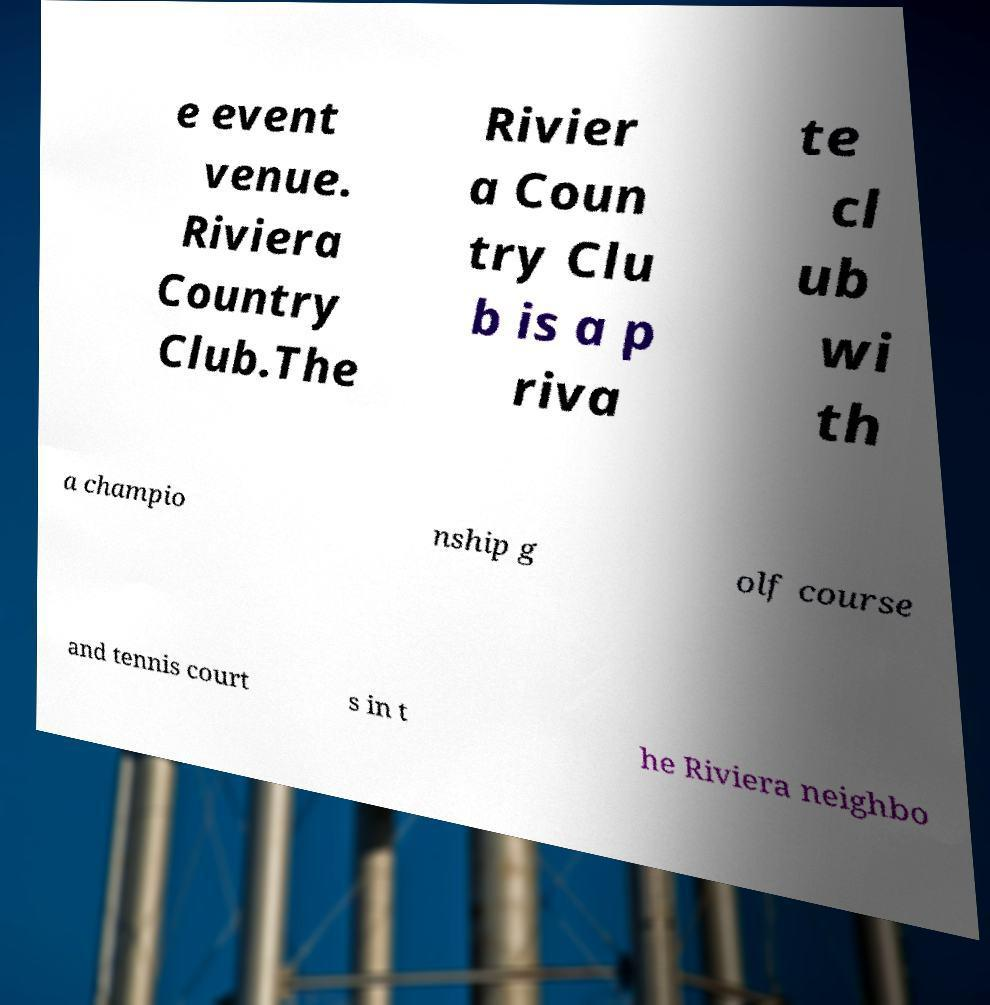I need the written content from this picture converted into text. Can you do that? e event venue. Riviera Country Club.The Rivier a Coun try Clu b is a p riva te cl ub wi th a champio nship g olf course and tennis court s in t he Riviera neighbo 